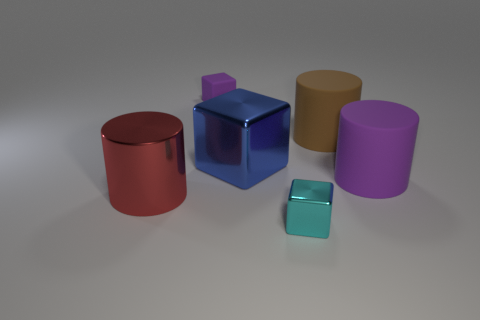There is a big thing in front of the purple rubber cylinder; is its color the same as the small block that is on the right side of the small purple cube?
Your response must be concise. No. Are there any big cylinders that have the same material as the large blue block?
Offer a terse response. Yes. There is a metallic cylinder in front of the purple object left of the small metal block; what size is it?
Offer a terse response. Large. Is the number of cyan blocks greater than the number of big green cubes?
Make the answer very short. Yes. Do the purple object that is behind the brown cylinder and the cyan metal thing have the same size?
Offer a terse response. Yes. What number of big cylinders are the same color as the tiny rubber thing?
Your response must be concise. 1. Is the brown rubber thing the same shape as the red shiny thing?
Keep it short and to the point. Yes. What is the size of the red thing that is the same shape as the big purple object?
Ensure brevity in your answer.  Large. Is the number of cyan shiny objects in front of the tiny purple matte thing greater than the number of big blocks in front of the big red metallic cylinder?
Keep it short and to the point. Yes. Do the large brown thing and the tiny thing in front of the red metallic cylinder have the same material?
Ensure brevity in your answer.  No. 